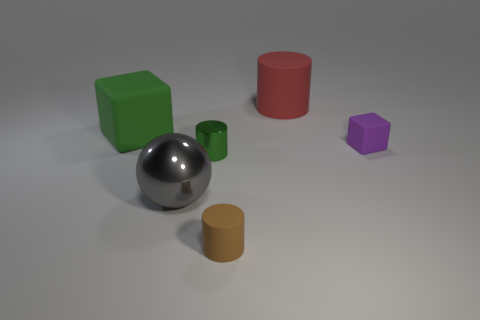Add 4 small purple objects. How many objects exist? 10 Subtract all blocks. How many objects are left? 4 Add 5 tiny shiny objects. How many tiny shiny objects are left? 6 Add 5 tiny brown matte objects. How many tiny brown matte objects exist? 6 Subtract 0 gray blocks. How many objects are left? 6 Subtract all big rubber things. Subtract all large matte objects. How many objects are left? 2 